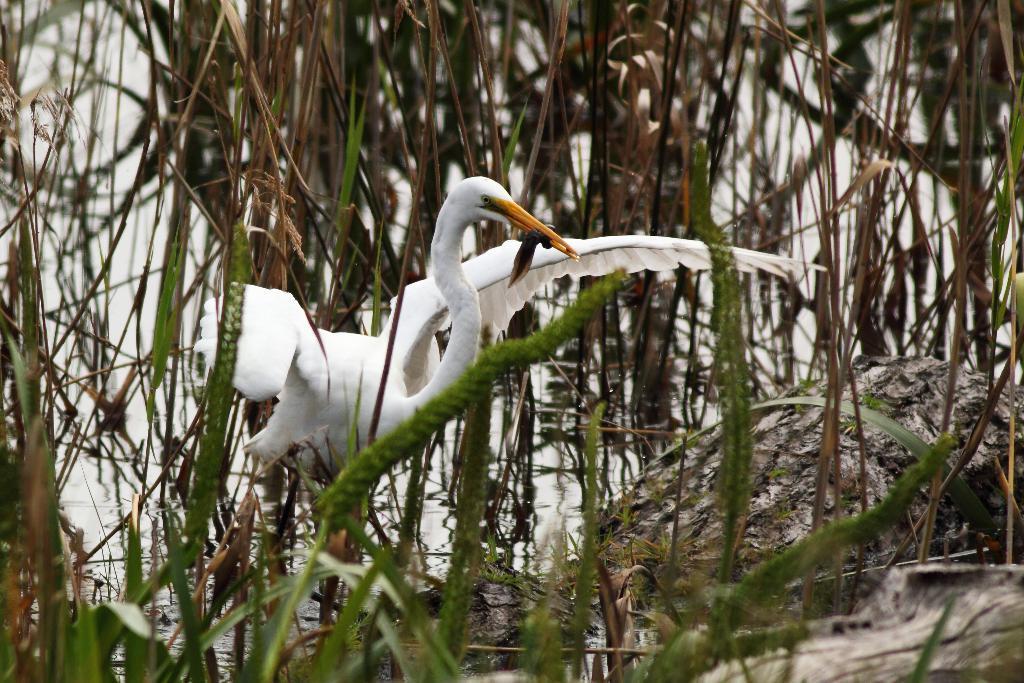Could you give a brief overview of what you see in this image? In this picture we can see some plants, there is an egret in the middle, at the bottom we can see water. 